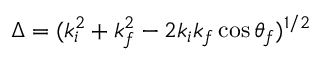Convert formula to latex. <formula><loc_0><loc_0><loc_500><loc_500>\Delta = ( k _ { i } ^ { 2 } + k _ { f } ^ { 2 } - 2 k _ { i } k _ { f } \cos \theta _ { f } ) ^ { 1 / 2 }</formula> 